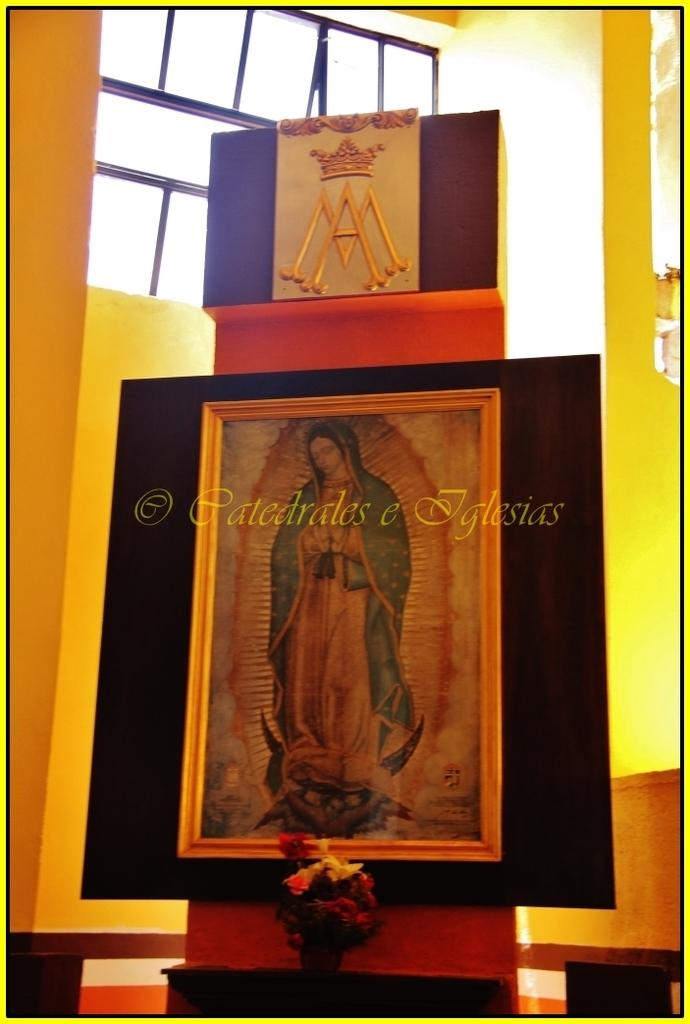<image>
Write a terse but informative summary of the picture. A picture of the Virgin Mary with the words Patedrales e Iglesias printed on it. 